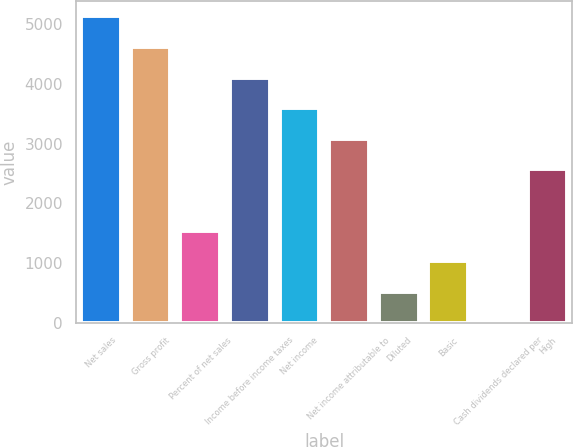Convert chart to OTSL. <chart><loc_0><loc_0><loc_500><loc_500><bar_chart><fcel>Net sales<fcel>Gross profit<fcel>Percent of net sales<fcel>Income before income taxes<fcel>Net income<fcel>Net income attributable to<fcel>Diluted<fcel>Basic<fcel>Cash dividends declared per<fcel>High<nl><fcel>5132<fcel>4618.86<fcel>1540.02<fcel>4105.72<fcel>3592.58<fcel>3079.44<fcel>513.74<fcel>1026.88<fcel>0.6<fcel>2566.3<nl></chart> 